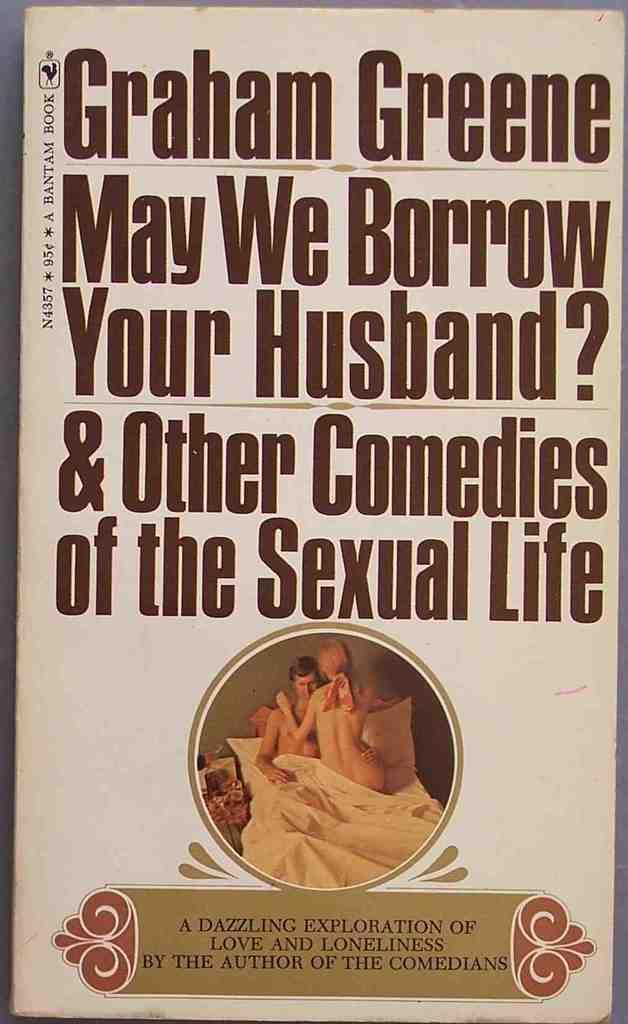Can you describe this image briefly? In this image there is a book at the top of the book there is some text, at the bottom there is man and a woman on a bed and there is text. 